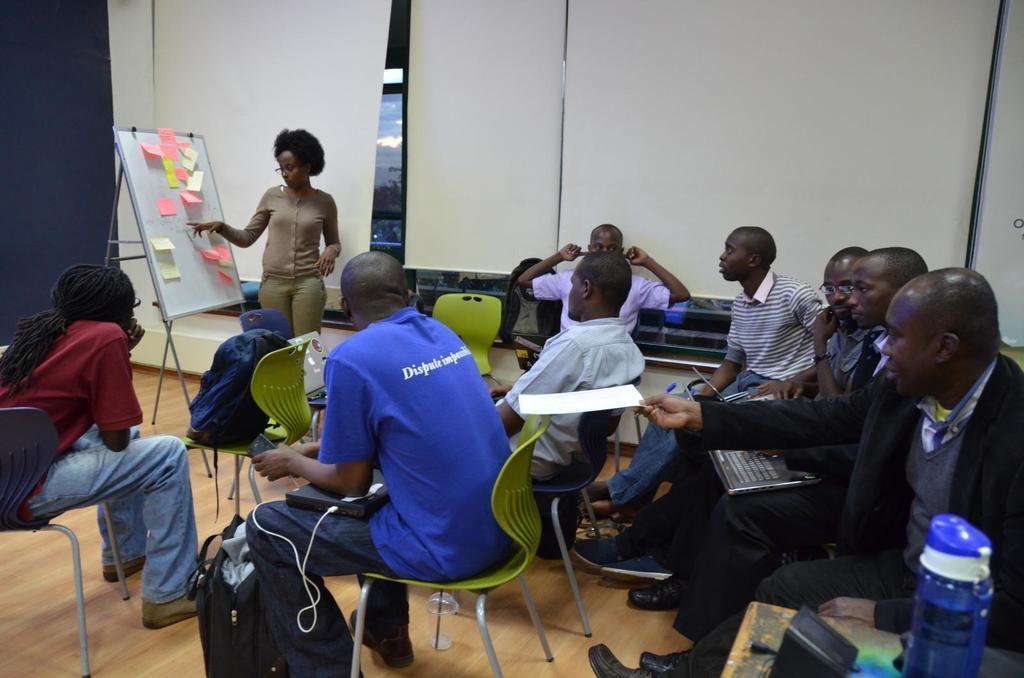Please provide a concise description of this image. In this image there are group of people who are sitting on a chairs. The woman standing in front of board is explaining the lesson to the people. A man sitting on the chair is using the laptop on the right side. In the background there are curtains. In the middle there is a bag and a wire. On the right side there is a bottle which is kept on the table. There are sticky notes on the board. 